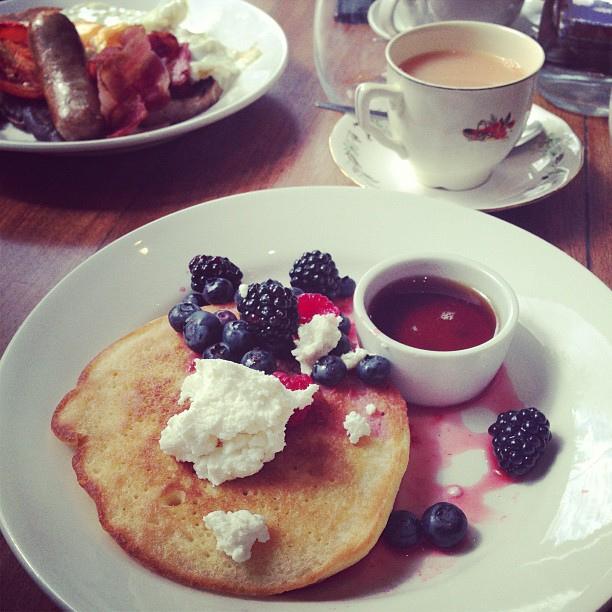Does the food look tasty?
Give a very brief answer. Yes. Which fruits are shown?
Give a very brief answer. Blueberries and blackberries. What flavor is the syrup?
Write a very short answer. Strawberry. What type of surface are the plates sitting on?
Be succinct. Table. How much syrup is on the plate?
Write a very short answer. Little. 